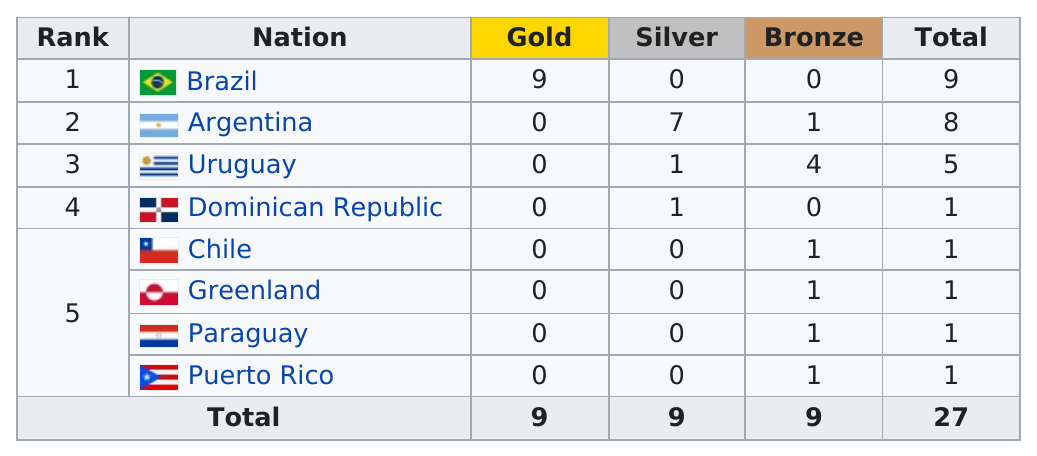Indicate a few pertinent items in this graphic. Brazil has the most gold. Argentina is the next country after Brazil in the South American region. Chile has been awarded 1 time. Brazil came in first place. Greenland has been awarded only one medal, which was the bronze medal. 